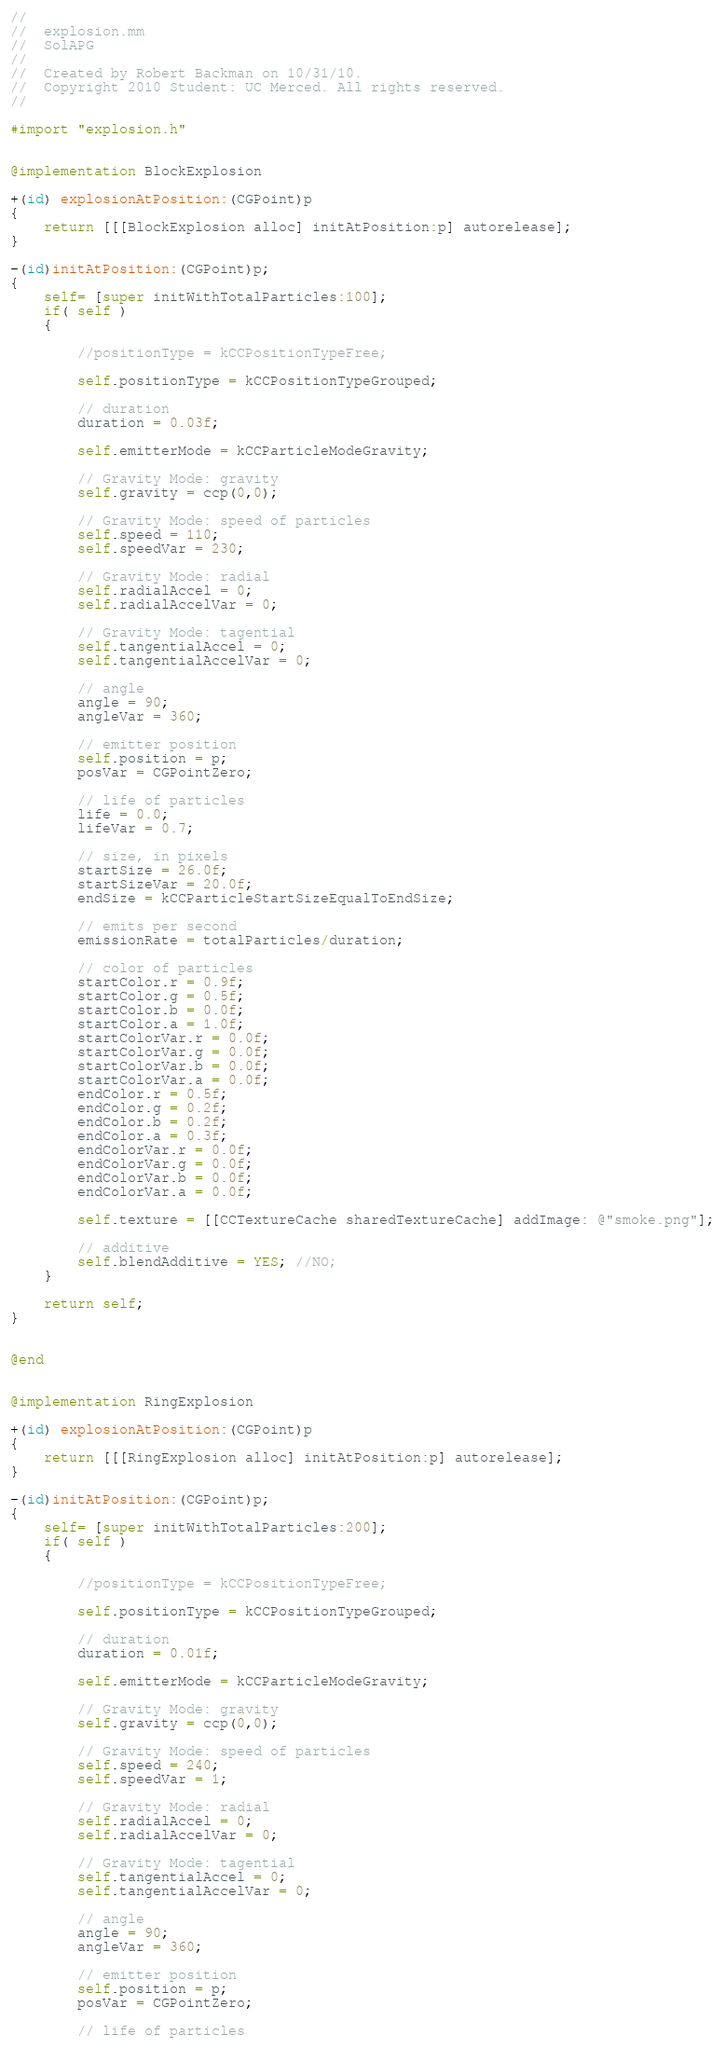<code> <loc_0><loc_0><loc_500><loc_500><_ObjectiveC_>//
//  explosion.mm
//  SolAPG
//
//  Created by Robert Backman on 10/31/10.
//  Copyright 2010 Student: UC Merced. All rights reserved.
//

#import "explosion.h"


@implementation BlockExplosion

+(id) explosionAtPosition:(CGPoint)p 
{
	return [[[BlockExplosion alloc] initAtPosition:p] autorelease];
}

-(id)initAtPosition:(CGPoint)p;
{
	self= [super initWithTotalParticles:100];
	if( self ) 
	{
		
		//positionType = kCCPositionTypeFree;
		
		self.positionType = kCCPositionTypeGrouped;
		
		// duration
		duration = 0.03f;
		
		self.emitterMode = kCCParticleModeGravity;
		
		// Gravity Mode: gravity
		self.gravity = ccp(0,0);
		
		// Gravity Mode: speed of particles
		self.speed = 110;
		self.speedVar = 230;
		
		// Gravity Mode: radial
		self.radialAccel = 0;
		self.radialAccelVar = 0;
		
		// Gravity Mode: tagential
		self.tangentialAccel = 0;
		self.tangentialAccelVar = 0;
		
		// angle
		angle = 90;
		angleVar = 360;
		
		// emitter position
		self.position = p;
		posVar = CGPointZero;
		
		// life of particles
		life = 0.0;
		lifeVar = 0.7;
		
		// size, in pixels
		startSize = 26.0f;
		startSizeVar = 20.0f;
		endSize = kCCParticleStartSizeEqualToEndSize;
		
		// emits per second
		emissionRate = totalParticles/duration;
		
		// color of particles
		startColor.r = 0.9f;
		startColor.g = 0.5f;
		startColor.b = 0.0f;
		startColor.a = 1.0f;
		startColorVar.r = 0.0f;
		startColorVar.g = 0.0f;
		startColorVar.b = 0.0f;
		startColorVar.a = 0.0f;
		endColor.r = 0.5f;
		endColor.g = 0.2f;
		endColor.b = 0.2f;
		endColor.a = 0.3f;
		endColorVar.r = 0.0f;
		endColorVar.g = 0.0f;
		endColorVar.b = 0.0f;
		endColorVar.a = 0.0f;
		
		self.texture = [[CCTextureCache sharedTextureCache] addImage: @"smoke.png"];
		
		// additive
		self.blendAdditive = YES; //NO;
	}
	
	return self;
}


@end


@implementation RingExplosion

+(id) explosionAtPosition:(CGPoint)p 
{
	return [[[RingExplosion alloc] initAtPosition:p] autorelease];
}

-(id)initAtPosition:(CGPoint)p;
{
	self= [super initWithTotalParticles:200];
	if( self ) 
	{
		
		//positionType = kCCPositionTypeFree;
		
		self.positionType = kCCPositionTypeGrouped;
		
		// duration
		duration = 0.01f;
		
		self.emitterMode = kCCParticleModeGravity;
		
		// Gravity Mode: gravity
		self.gravity = ccp(0,0);
		
		// Gravity Mode: speed of particles
		self.speed = 240;
		self.speedVar = 1;
		
		// Gravity Mode: radial
		self.radialAccel = 0;
		self.radialAccelVar = 0;
		
		// Gravity Mode: tagential
		self.tangentialAccel = 0;
		self.tangentialAccelVar = 0;
		
		// angle
		angle = 90;
		angleVar = 360;
		
		// emitter position
		self.position = p;
		posVar = CGPointZero;
		
		// life of particles</code> 